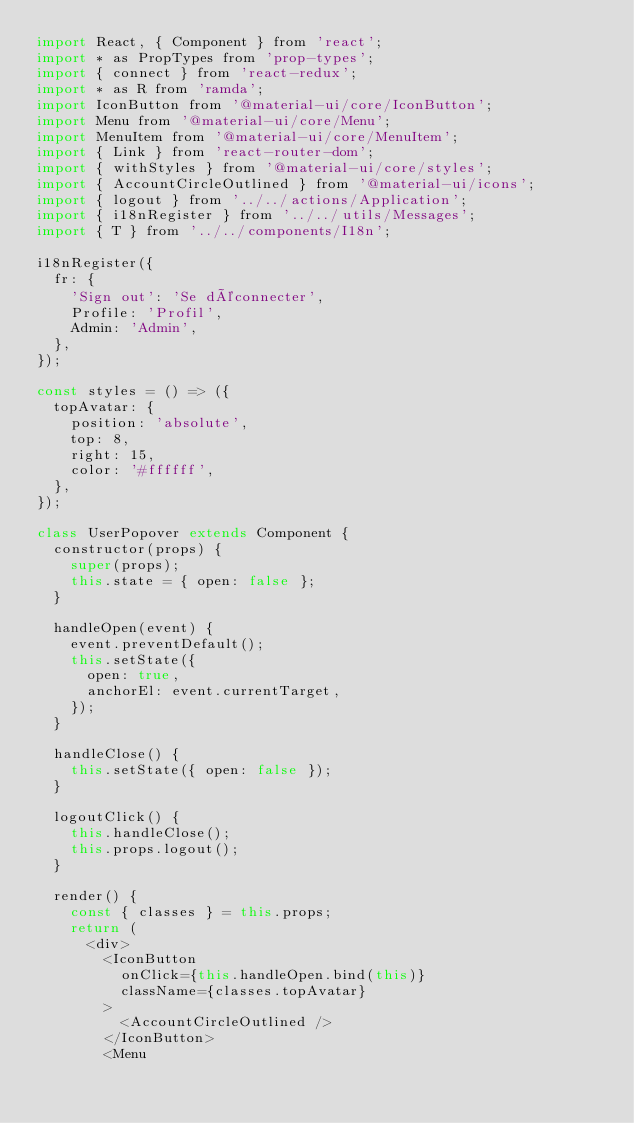Convert code to text. <code><loc_0><loc_0><loc_500><loc_500><_JavaScript_>import React, { Component } from 'react';
import * as PropTypes from 'prop-types';
import { connect } from 'react-redux';
import * as R from 'ramda';
import IconButton from '@material-ui/core/IconButton';
import Menu from '@material-ui/core/Menu';
import MenuItem from '@material-ui/core/MenuItem';
import { Link } from 'react-router-dom';
import { withStyles } from '@material-ui/core/styles';
import { AccountCircleOutlined } from '@material-ui/icons';
import { logout } from '../../actions/Application';
import { i18nRegister } from '../../utils/Messages';
import { T } from '../../components/I18n';

i18nRegister({
  fr: {
    'Sign out': 'Se déconnecter',
    Profile: 'Profil',
    Admin: 'Admin',
  },
});

const styles = () => ({
  topAvatar: {
    position: 'absolute',
    top: 8,
    right: 15,
    color: '#ffffff',
  },
});

class UserPopover extends Component {
  constructor(props) {
    super(props);
    this.state = { open: false };
  }

  handleOpen(event) {
    event.preventDefault();
    this.setState({
      open: true,
      anchorEl: event.currentTarget,
    });
  }

  handleClose() {
    this.setState({ open: false });
  }

  logoutClick() {
    this.handleClose();
    this.props.logout();
  }

  render() {
    const { classes } = this.props;
    return (
      <div>
        <IconButton
          onClick={this.handleOpen.bind(this)}
          className={classes.topAvatar}
        >
          <AccountCircleOutlined />
        </IconButton>
        <Menu</code> 